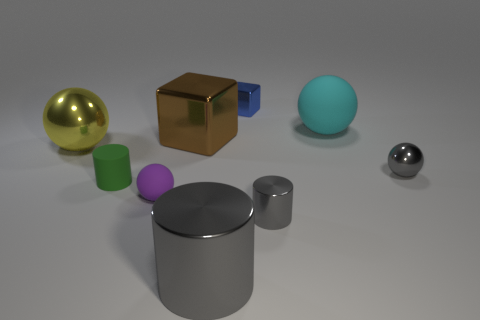Add 1 large green matte cubes. How many objects exist? 10 Subtract all balls. How many objects are left? 5 Add 6 small green things. How many small green things are left? 7 Add 5 small objects. How many small objects exist? 10 Subtract 1 yellow spheres. How many objects are left? 8 Subtract all small gray balls. Subtract all large things. How many objects are left? 4 